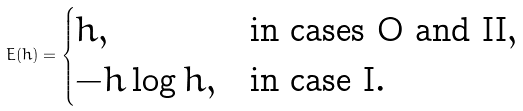<formula> <loc_0><loc_0><loc_500><loc_500>E ( h ) = \begin{cases} h , & \text {in cases O and II} , \\ - h \log h , & \text {in case I} . \\ \end{cases}</formula> 